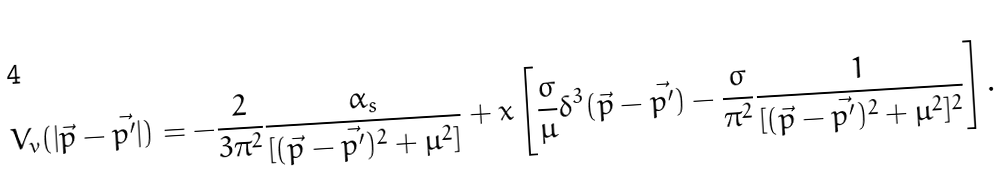<formula> <loc_0><loc_0><loc_500><loc_500>V _ { v } ( | \vec { p } - \vec { p ^ { \prime } } | ) = - \frac { 2 } { 3 \pi ^ { 2 } } \frac { \alpha _ { s } } { [ ( \vec { p } - \vec { p ^ { \prime } } ) ^ { 2 } + \mu ^ { 2 } ] } + x \left [ \frac { \sigma } { \mu } \delta ^ { 3 } ( \vec { p } - \vec { p ^ { \prime } } ) - \frac { \sigma } { \pi ^ { 2 } } \frac { 1 } { [ ( \vec { p } - \vec { p ^ { \prime } } ) ^ { 2 } + \mu ^ { 2 } ] ^ { 2 } } \right ] .</formula> 